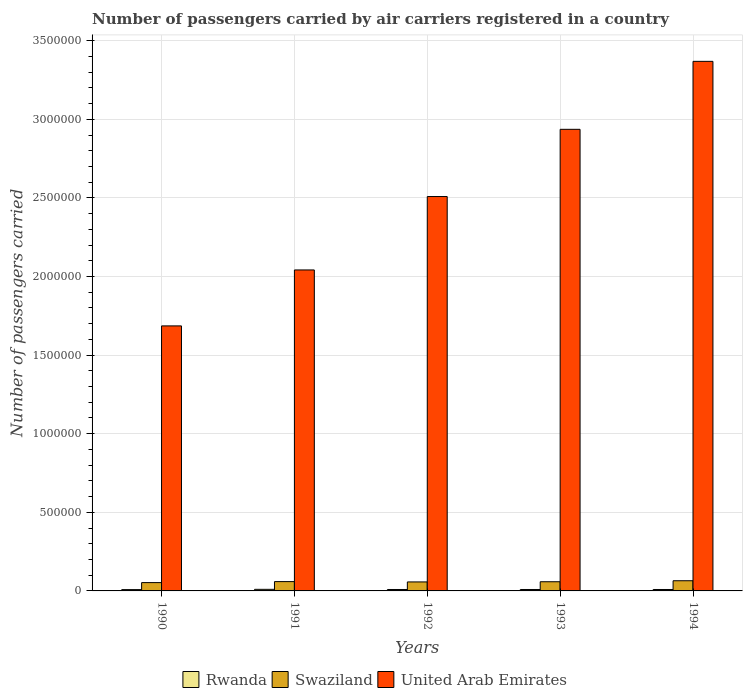How many groups of bars are there?
Offer a terse response. 5. How many bars are there on the 1st tick from the left?
Provide a short and direct response. 3. How many bars are there on the 3rd tick from the right?
Offer a very short reply. 3. What is the label of the 2nd group of bars from the left?
Keep it short and to the point. 1991. In how many cases, is the number of bars for a given year not equal to the number of legend labels?
Your answer should be very brief. 0. What is the number of passengers carried by air carriers in United Arab Emirates in 1991?
Offer a very short reply. 2.04e+06. Across all years, what is the maximum number of passengers carried by air carriers in Swaziland?
Give a very brief answer. 6.48e+04. Across all years, what is the minimum number of passengers carried by air carriers in United Arab Emirates?
Provide a short and direct response. 1.69e+06. In which year was the number of passengers carried by air carriers in Swaziland minimum?
Keep it short and to the point. 1990. What is the total number of passengers carried by air carriers in Swaziland in the graph?
Offer a very short reply. 2.93e+05. What is the difference between the number of passengers carried by air carriers in Swaziland in 1990 and that in 1993?
Ensure brevity in your answer.  -5500. What is the difference between the number of passengers carried by air carriers in United Arab Emirates in 1993 and the number of passengers carried by air carriers in Rwanda in 1991?
Ensure brevity in your answer.  2.93e+06. What is the average number of passengers carried by air carriers in Rwanda per year?
Your answer should be very brief. 9160. In the year 1992, what is the difference between the number of passengers carried by air carriers in Swaziland and number of passengers carried by air carriers in United Arab Emirates?
Provide a short and direct response. -2.45e+06. What is the ratio of the number of passengers carried by air carriers in Swaziland in 1991 to that in 1994?
Your response must be concise. 0.92. What is the difference between the highest and the second highest number of passengers carried by air carriers in Swaziland?
Make the answer very short. 5500. What is the difference between the highest and the lowest number of passengers carried by air carriers in United Arab Emirates?
Your answer should be compact. 1.68e+06. Is the sum of the number of passengers carried by air carriers in Rwanda in 1992 and 1994 greater than the maximum number of passengers carried by air carriers in Swaziland across all years?
Your answer should be compact. No. What does the 2nd bar from the left in 1991 represents?
Your response must be concise. Swaziland. What does the 2nd bar from the right in 1991 represents?
Offer a terse response. Swaziland. Is it the case that in every year, the sum of the number of passengers carried by air carriers in United Arab Emirates and number of passengers carried by air carriers in Rwanda is greater than the number of passengers carried by air carriers in Swaziland?
Provide a succinct answer. Yes. How many years are there in the graph?
Keep it short and to the point. 5. What is the difference between two consecutive major ticks on the Y-axis?
Make the answer very short. 5.00e+05. Does the graph contain grids?
Offer a very short reply. Yes. Where does the legend appear in the graph?
Make the answer very short. Bottom center. How many legend labels are there?
Your response must be concise. 3. How are the legend labels stacked?
Your response must be concise. Horizontal. What is the title of the graph?
Your answer should be very brief. Number of passengers carried by air carriers registered in a country. What is the label or title of the Y-axis?
Offer a very short reply. Number of passengers carried. What is the Number of passengers carried in Rwanda in 1990?
Your answer should be very brief. 8400. What is the Number of passengers carried in Swaziland in 1990?
Keep it short and to the point. 5.29e+04. What is the Number of passengers carried of United Arab Emirates in 1990?
Give a very brief answer. 1.69e+06. What is the Number of passengers carried of Rwanda in 1991?
Your response must be concise. 1.01e+04. What is the Number of passengers carried of Swaziland in 1991?
Your answer should be very brief. 5.93e+04. What is the Number of passengers carried of United Arab Emirates in 1991?
Keep it short and to the point. 2.04e+06. What is the Number of passengers carried in Rwanda in 1992?
Keep it short and to the point. 9100. What is the Number of passengers carried in Swaziland in 1992?
Ensure brevity in your answer.  5.72e+04. What is the Number of passengers carried in United Arab Emirates in 1992?
Ensure brevity in your answer.  2.51e+06. What is the Number of passengers carried in Rwanda in 1993?
Your response must be concise. 9100. What is the Number of passengers carried of Swaziland in 1993?
Ensure brevity in your answer.  5.84e+04. What is the Number of passengers carried of United Arab Emirates in 1993?
Your answer should be very brief. 2.94e+06. What is the Number of passengers carried of Rwanda in 1994?
Ensure brevity in your answer.  9100. What is the Number of passengers carried of Swaziland in 1994?
Your answer should be compact. 6.48e+04. What is the Number of passengers carried in United Arab Emirates in 1994?
Offer a terse response. 3.37e+06. Across all years, what is the maximum Number of passengers carried in Rwanda?
Keep it short and to the point. 1.01e+04. Across all years, what is the maximum Number of passengers carried in Swaziland?
Provide a short and direct response. 6.48e+04. Across all years, what is the maximum Number of passengers carried of United Arab Emirates?
Provide a succinct answer. 3.37e+06. Across all years, what is the minimum Number of passengers carried of Rwanda?
Make the answer very short. 8400. Across all years, what is the minimum Number of passengers carried in Swaziland?
Provide a succinct answer. 5.29e+04. Across all years, what is the minimum Number of passengers carried of United Arab Emirates?
Ensure brevity in your answer.  1.69e+06. What is the total Number of passengers carried in Rwanda in the graph?
Offer a very short reply. 4.58e+04. What is the total Number of passengers carried of Swaziland in the graph?
Provide a succinct answer. 2.93e+05. What is the total Number of passengers carried in United Arab Emirates in the graph?
Your answer should be very brief. 1.25e+07. What is the difference between the Number of passengers carried of Rwanda in 1990 and that in 1991?
Keep it short and to the point. -1700. What is the difference between the Number of passengers carried of Swaziland in 1990 and that in 1991?
Provide a short and direct response. -6400. What is the difference between the Number of passengers carried of United Arab Emirates in 1990 and that in 1991?
Ensure brevity in your answer.  -3.56e+05. What is the difference between the Number of passengers carried in Rwanda in 1990 and that in 1992?
Offer a very short reply. -700. What is the difference between the Number of passengers carried in Swaziland in 1990 and that in 1992?
Keep it short and to the point. -4300. What is the difference between the Number of passengers carried of United Arab Emirates in 1990 and that in 1992?
Your answer should be compact. -8.23e+05. What is the difference between the Number of passengers carried of Rwanda in 1990 and that in 1993?
Make the answer very short. -700. What is the difference between the Number of passengers carried in Swaziland in 1990 and that in 1993?
Give a very brief answer. -5500. What is the difference between the Number of passengers carried of United Arab Emirates in 1990 and that in 1993?
Give a very brief answer. -1.25e+06. What is the difference between the Number of passengers carried of Rwanda in 1990 and that in 1994?
Offer a terse response. -700. What is the difference between the Number of passengers carried of Swaziland in 1990 and that in 1994?
Your response must be concise. -1.19e+04. What is the difference between the Number of passengers carried of United Arab Emirates in 1990 and that in 1994?
Offer a very short reply. -1.68e+06. What is the difference between the Number of passengers carried in Rwanda in 1991 and that in 1992?
Your answer should be compact. 1000. What is the difference between the Number of passengers carried of Swaziland in 1991 and that in 1992?
Keep it short and to the point. 2100. What is the difference between the Number of passengers carried in United Arab Emirates in 1991 and that in 1992?
Offer a terse response. -4.67e+05. What is the difference between the Number of passengers carried in Rwanda in 1991 and that in 1993?
Ensure brevity in your answer.  1000. What is the difference between the Number of passengers carried in Swaziland in 1991 and that in 1993?
Your answer should be compact. 900. What is the difference between the Number of passengers carried in United Arab Emirates in 1991 and that in 1993?
Keep it short and to the point. -8.94e+05. What is the difference between the Number of passengers carried in Rwanda in 1991 and that in 1994?
Your answer should be compact. 1000. What is the difference between the Number of passengers carried in Swaziland in 1991 and that in 1994?
Keep it short and to the point. -5500. What is the difference between the Number of passengers carried in United Arab Emirates in 1991 and that in 1994?
Make the answer very short. -1.33e+06. What is the difference between the Number of passengers carried of Swaziland in 1992 and that in 1993?
Keep it short and to the point. -1200. What is the difference between the Number of passengers carried in United Arab Emirates in 1992 and that in 1993?
Keep it short and to the point. -4.28e+05. What is the difference between the Number of passengers carried in Rwanda in 1992 and that in 1994?
Make the answer very short. 0. What is the difference between the Number of passengers carried in Swaziland in 1992 and that in 1994?
Make the answer very short. -7600. What is the difference between the Number of passengers carried in United Arab Emirates in 1992 and that in 1994?
Your answer should be compact. -8.60e+05. What is the difference between the Number of passengers carried of Rwanda in 1993 and that in 1994?
Your response must be concise. 0. What is the difference between the Number of passengers carried in Swaziland in 1993 and that in 1994?
Offer a very short reply. -6400. What is the difference between the Number of passengers carried of United Arab Emirates in 1993 and that in 1994?
Your response must be concise. -4.32e+05. What is the difference between the Number of passengers carried of Rwanda in 1990 and the Number of passengers carried of Swaziland in 1991?
Keep it short and to the point. -5.09e+04. What is the difference between the Number of passengers carried in Rwanda in 1990 and the Number of passengers carried in United Arab Emirates in 1991?
Provide a succinct answer. -2.03e+06. What is the difference between the Number of passengers carried in Swaziland in 1990 and the Number of passengers carried in United Arab Emirates in 1991?
Give a very brief answer. -1.99e+06. What is the difference between the Number of passengers carried in Rwanda in 1990 and the Number of passengers carried in Swaziland in 1992?
Provide a short and direct response. -4.88e+04. What is the difference between the Number of passengers carried in Rwanda in 1990 and the Number of passengers carried in United Arab Emirates in 1992?
Your answer should be compact. -2.50e+06. What is the difference between the Number of passengers carried in Swaziland in 1990 and the Number of passengers carried in United Arab Emirates in 1992?
Your answer should be very brief. -2.46e+06. What is the difference between the Number of passengers carried of Rwanda in 1990 and the Number of passengers carried of Swaziland in 1993?
Your answer should be very brief. -5.00e+04. What is the difference between the Number of passengers carried of Rwanda in 1990 and the Number of passengers carried of United Arab Emirates in 1993?
Provide a succinct answer. -2.93e+06. What is the difference between the Number of passengers carried of Swaziland in 1990 and the Number of passengers carried of United Arab Emirates in 1993?
Your answer should be very brief. -2.88e+06. What is the difference between the Number of passengers carried in Rwanda in 1990 and the Number of passengers carried in Swaziland in 1994?
Provide a short and direct response. -5.64e+04. What is the difference between the Number of passengers carried in Rwanda in 1990 and the Number of passengers carried in United Arab Emirates in 1994?
Give a very brief answer. -3.36e+06. What is the difference between the Number of passengers carried of Swaziland in 1990 and the Number of passengers carried of United Arab Emirates in 1994?
Keep it short and to the point. -3.32e+06. What is the difference between the Number of passengers carried of Rwanda in 1991 and the Number of passengers carried of Swaziland in 1992?
Your response must be concise. -4.71e+04. What is the difference between the Number of passengers carried in Rwanda in 1991 and the Number of passengers carried in United Arab Emirates in 1992?
Provide a short and direct response. -2.50e+06. What is the difference between the Number of passengers carried of Swaziland in 1991 and the Number of passengers carried of United Arab Emirates in 1992?
Keep it short and to the point. -2.45e+06. What is the difference between the Number of passengers carried in Rwanda in 1991 and the Number of passengers carried in Swaziland in 1993?
Your answer should be very brief. -4.83e+04. What is the difference between the Number of passengers carried of Rwanda in 1991 and the Number of passengers carried of United Arab Emirates in 1993?
Keep it short and to the point. -2.93e+06. What is the difference between the Number of passengers carried of Swaziland in 1991 and the Number of passengers carried of United Arab Emirates in 1993?
Your answer should be compact. -2.88e+06. What is the difference between the Number of passengers carried in Rwanda in 1991 and the Number of passengers carried in Swaziland in 1994?
Provide a short and direct response. -5.47e+04. What is the difference between the Number of passengers carried of Rwanda in 1991 and the Number of passengers carried of United Arab Emirates in 1994?
Make the answer very short. -3.36e+06. What is the difference between the Number of passengers carried of Swaziland in 1991 and the Number of passengers carried of United Arab Emirates in 1994?
Offer a very short reply. -3.31e+06. What is the difference between the Number of passengers carried of Rwanda in 1992 and the Number of passengers carried of Swaziland in 1993?
Give a very brief answer. -4.93e+04. What is the difference between the Number of passengers carried in Rwanda in 1992 and the Number of passengers carried in United Arab Emirates in 1993?
Offer a very short reply. -2.93e+06. What is the difference between the Number of passengers carried in Swaziland in 1992 and the Number of passengers carried in United Arab Emirates in 1993?
Provide a short and direct response. -2.88e+06. What is the difference between the Number of passengers carried of Rwanda in 1992 and the Number of passengers carried of Swaziland in 1994?
Make the answer very short. -5.57e+04. What is the difference between the Number of passengers carried of Rwanda in 1992 and the Number of passengers carried of United Arab Emirates in 1994?
Give a very brief answer. -3.36e+06. What is the difference between the Number of passengers carried of Swaziland in 1992 and the Number of passengers carried of United Arab Emirates in 1994?
Provide a succinct answer. -3.31e+06. What is the difference between the Number of passengers carried in Rwanda in 1993 and the Number of passengers carried in Swaziland in 1994?
Your answer should be very brief. -5.57e+04. What is the difference between the Number of passengers carried in Rwanda in 1993 and the Number of passengers carried in United Arab Emirates in 1994?
Keep it short and to the point. -3.36e+06. What is the difference between the Number of passengers carried in Swaziland in 1993 and the Number of passengers carried in United Arab Emirates in 1994?
Offer a very short reply. -3.31e+06. What is the average Number of passengers carried in Rwanda per year?
Offer a terse response. 9160. What is the average Number of passengers carried of Swaziland per year?
Provide a succinct answer. 5.85e+04. What is the average Number of passengers carried of United Arab Emirates per year?
Ensure brevity in your answer.  2.51e+06. In the year 1990, what is the difference between the Number of passengers carried in Rwanda and Number of passengers carried in Swaziland?
Ensure brevity in your answer.  -4.45e+04. In the year 1990, what is the difference between the Number of passengers carried of Rwanda and Number of passengers carried of United Arab Emirates?
Your answer should be very brief. -1.68e+06. In the year 1990, what is the difference between the Number of passengers carried of Swaziland and Number of passengers carried of United Arab Emirates?
Your answer should be very brief. -1.63e+06. In the year 1991, what is the difference between the Number of passengers carried in Rwanda and Number of passengers carried in Swaziland?
Give a very brief answer. -4.92e+04. In the year 1991, what is the difference between the Number of passengers carried of Rwanda and Number of passengers carried of United Arab Emirates?
Keep it short and to the point. -2.03e+06. In the year 1991, what is the difference between the Number of passengers carried in Swaziland and Number of passengers carried in United Arab Emirates?
Make the answer very short. -1.98e+06. In the year 1992, what is the difference between the Number of passengers carried in Rwanda and Number of passengers carried in Swaziland?
Your response must be concise. -4.81e+04. In the year 1992, what is the difference between the Number of passengers carried of Rwanda and Number of passengers carried of United Arab Emirates?
Offer a very short reply. -2.50e+06. In the year 1992, what is the difference between the Number of passengers carried in Swaziland and Number of passengers carried in United Arab Emirates?
Your answer should be very brief. -2.45e+06. In the year 1993, what is the difference between the Number of passengers carried of Rwanda and Number of passengers carried of Swaziland?
Keep it short and to the point. -4.93e+04. In the year 1993, what is the difference between the Number of passengers carried in Rwanda and Number of passengers carried in United Arab Emirates?
Keep it short and to the point. -2.93e+06. In the year 1993, what is the difference between the Number of passengers carried of Swaziland and Number of passengers carried of United Arab Emirates?
Offer a very short reply. -2.88e+06. In the year 1994, what is the difference between the Number of passengers carried in Rwanda and Number of passengers carried in Swaziland?
Ensure brevity in your answer.  -5.57e+04. In the year 1994, what is the difference between the Number of passengers carried in Rwanda and Number of passengers carried in United Arab Emirates?
Make the answer very short. -3.36e+06. In the year 1994, what is the difference between the Number of passengers carried of Swaziland and Number of passengers carried of United Arab Emirates?
Provide a short and direct response. -3.30e+06. What is the ratio of the Number of passengers carried in Rwanda in 1990 to that in 1991?
Keep it short and to the point. 0.83. What is the ratio of the Number of passengers carried of Swaziland in 1990 to that in 1991?
Keep it short and to the point. 0.89. What is the ratio of the Number of passengers carried in United Arab Emirates in 1990 to that in 1991?
Offer a terse response. 0.83. What is the ratio of the Number of passengers carried of Swaziland in 1990 to that in 1992?
Give a very brief answer. 0.92. What is the ratio of the Number of passengers carried in United Arab Emirates in 1990 to that in 1992?
Give a very brief answer. 0.67. What is the ratio of the Number of passengers carried in Swaziland in 1990 to that in 1993?
Offer a very short reply. 0.91. What is the ratio of the Number of passengers carried of United Arab Emirates in 1990 to that in 1993?
Your answer should be compact. 0.57. What is the ratio of the Number of passengers carried in Rwanda in 1990 to that in 1994?
Provide a short and direct response. 0.92. What is the ratio of the Number of passengers carried of Swaziland in 1990 to that in 1994?
Your answer should be very brief. 0.82. What is the ratio of the Number of passengers carried of United Arab Emirates in 1990 to that in 1994?
Provide a succinct answer. 0.5. What is the ratio of the Number of passengers carried of Rwanda in 1991 to that in 1992?
Your response must be concise. 1.11. What is the ratio of the Number of passengers carried of Swaziland in 1991 to that in 1992?
Give a very brief answer. 1.04. What is the ratio of the Number of passengers carried in United Arab Emirates in 1991 to that in 1992?
Provide a short and direct response. 0.81. What is the ratio of the Number of passengers carried in Rwanda in 1991 to that in 1993?
Your answer should be very brief. 1.11. What is the ratio of the Number of passengers carried of Swaziland in 1991 to that in 1993?
Make the answer very short. 1.02. What is the ratio of the Number of passengers carried in United Arab Emirates in 1991 to that in 1993?
Offer a very short reply. 0.7. What is the ratio of the Number of passengers carried in Rwanda in 1991 to that in 1994?
Provide a succinct answer. 1.11. What is the ratio of the Number of passengers carried of Swaziland in 1991 to that in 1994?
Make the answer very short. 0.92. What is the ratio of the Number of passengers carried of United Arab Emirates in 1991 to that in 1994?
Provide a short and direct response. 0.61. What is the ratio of the Number of passengers carried in Swaziland in 1992 to that in 1993?
Your answer should be compact. 0.98. What is the ratio of the Number of passengers carried in United Arab Emirates in 1992 to that in 1993?
Offer a very short reply. 0.85. What is the ratio of the Number of passengers carried in Swaziland in 1992 to that in 1994?
Your response must be concise. 0.88. What is the ratio of the Number of passengers carried in United Arab Emirates in 1992 to that in 1994?
Give a very brief answer. 0.74. What is the ratio of the Number of passengers carried of Rwanda in 1993 to that in 1994?
Ensure brevity in your answer.  1. What is the ratio of the Number of passengers carried in Swaziland in 1993 to that in 1994?
Provide a short and direct response. 0.9. What is the ratio of the Number of passengers carried of United Arab Emirates in 1993 to that in 1994?
Make the answer very short. 0.87. What is the difference between the highest and the second highest Number of passengers carried in Swaziland?
Provide a succinct answer. 5500. What is the difference between the highest and the second highest Number of passengers carried in United Arab Emirates?
Keep it short and to the point. 4.32e+05. What is the difference between the highest and the lowest Number of passengers carried of Rwanda?
Make the answer very short. 1700. What is the difference between the highest and the lowest Number of passengers carried of Swaziland?
Your answer should be compact. 1.19e+04. What is the difference between the highest and the lowest Number of passengers carried in United Arab Emirates?
Ensure brevity in your answer.  1.68e+06. 